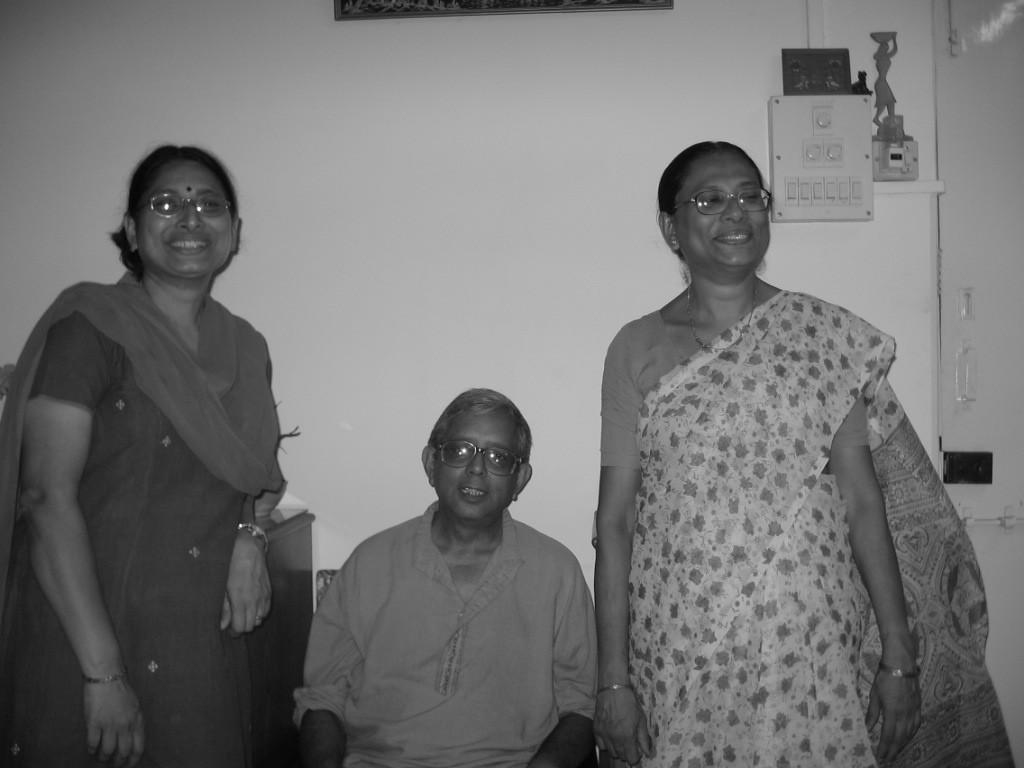Can you describe this image briefly? In the center of the image a man is sitting on a chair. On the left and right side of the image there are two ladies are standing. On the right side of the image we can see the door, sculpture, circuit board, switches, frame are present. In the background of the image wall is there. On the left side of the image table is present. 